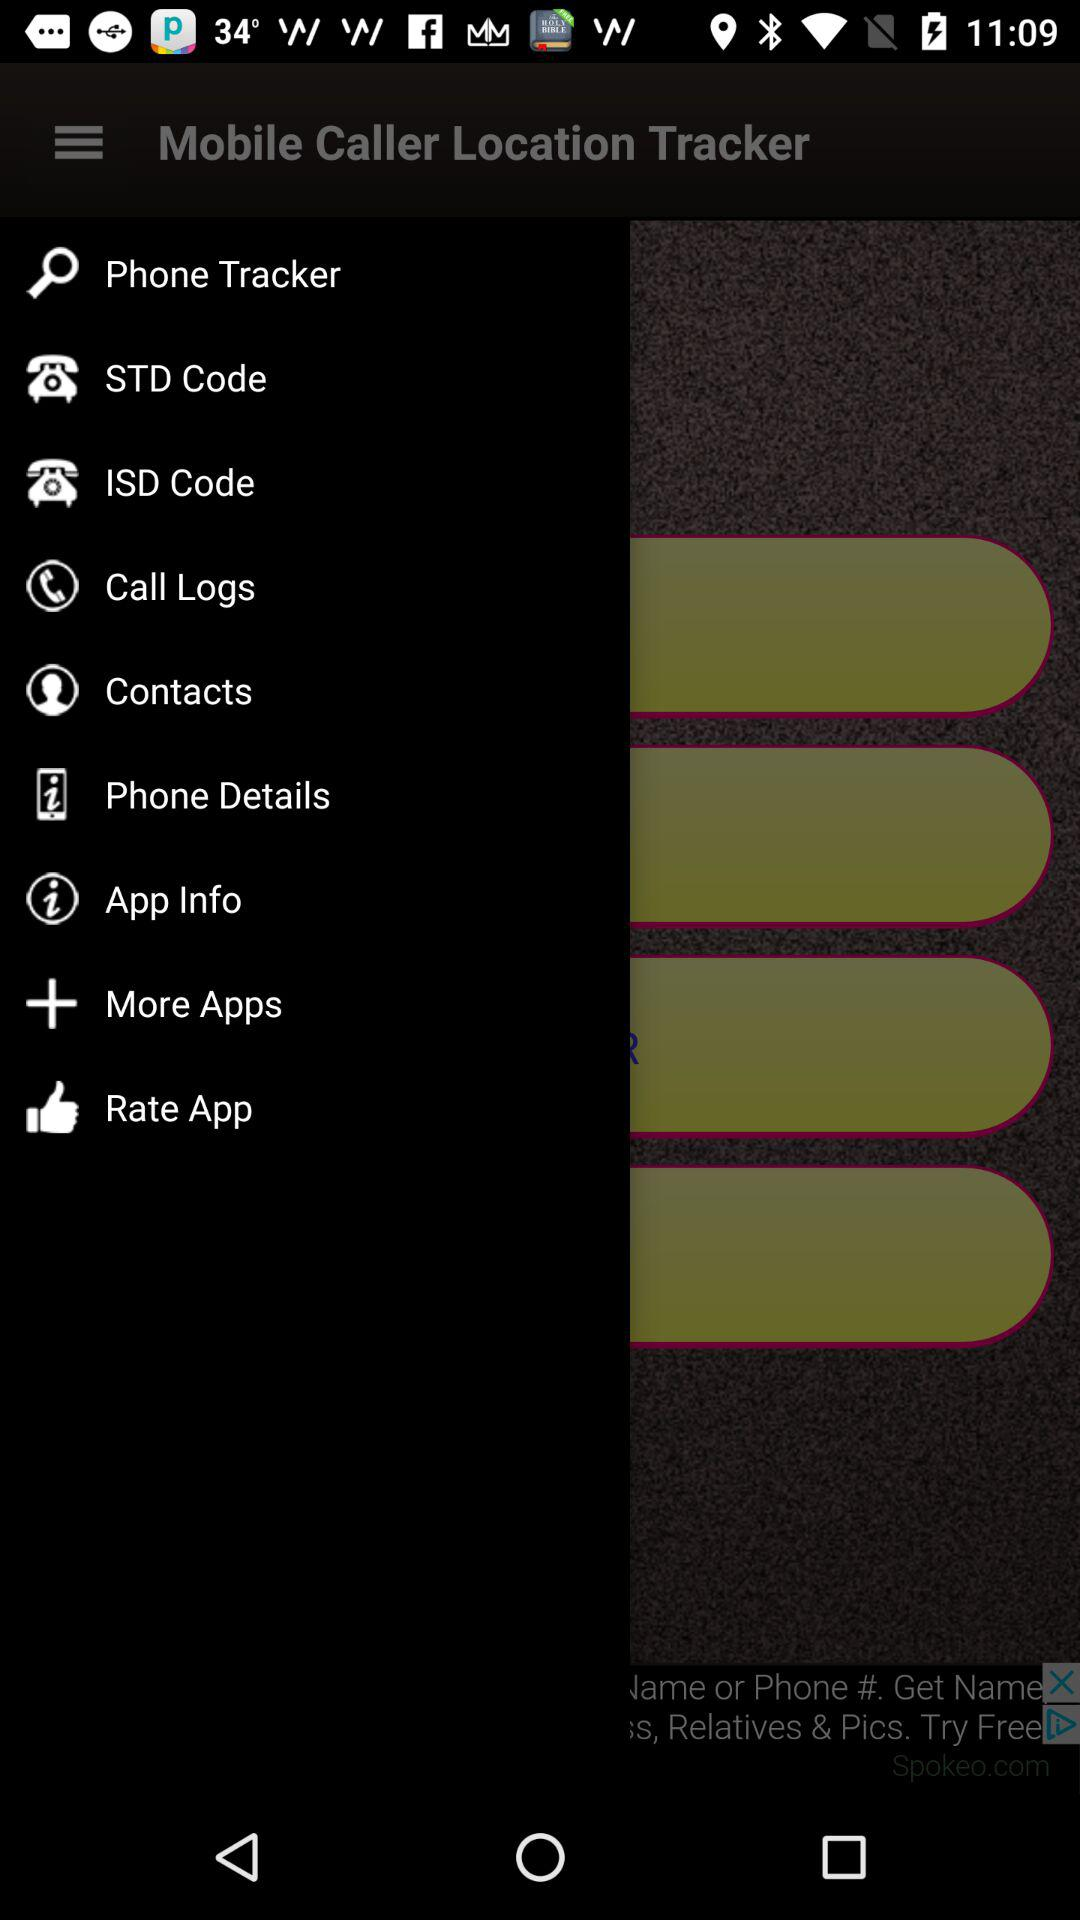What is the app name? The app name is "Mobile Caller Location Tracker". 